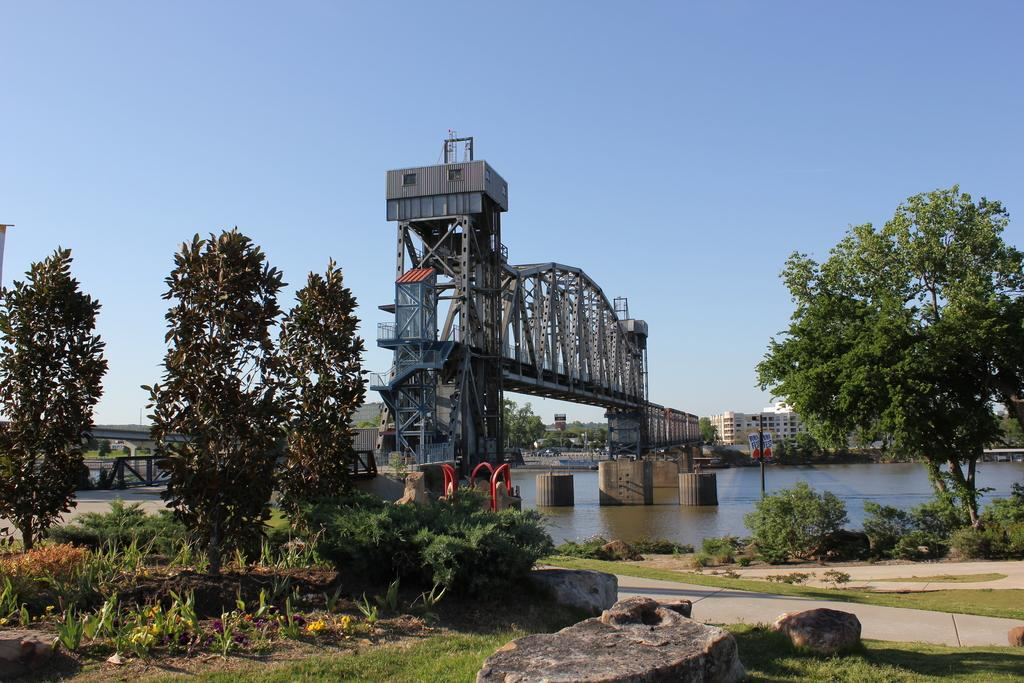What type of natural elements can be seen in the image? There are trees, plants, and rocks visible in the image. What type of man-made structures are present in the image? There are buildings, a bridge, rods, poles, and boards visible in the image. What is visible at the bottom of the image? There is water and ground visible at the bottom of the image. What is visible at the top of the image? The sky is visible at the top of the image. How many birds are sitting on the rods in the image? There are no birds present in the image; only trees, buildings, a bridge, plants, rocks, rods, poles, boards, water, ground, and sky are visible. What type of vacation destination is depicted in the image? The image does not depict a vacation destination; it shows a scene with various natural and man-made elements. Can you see a bubble floating in the sky in the image? There is no bubble visible in the image; only trees, buildings, a bridge, plants, rocks, rods, poles, boards, water, ground, and sky are present. 